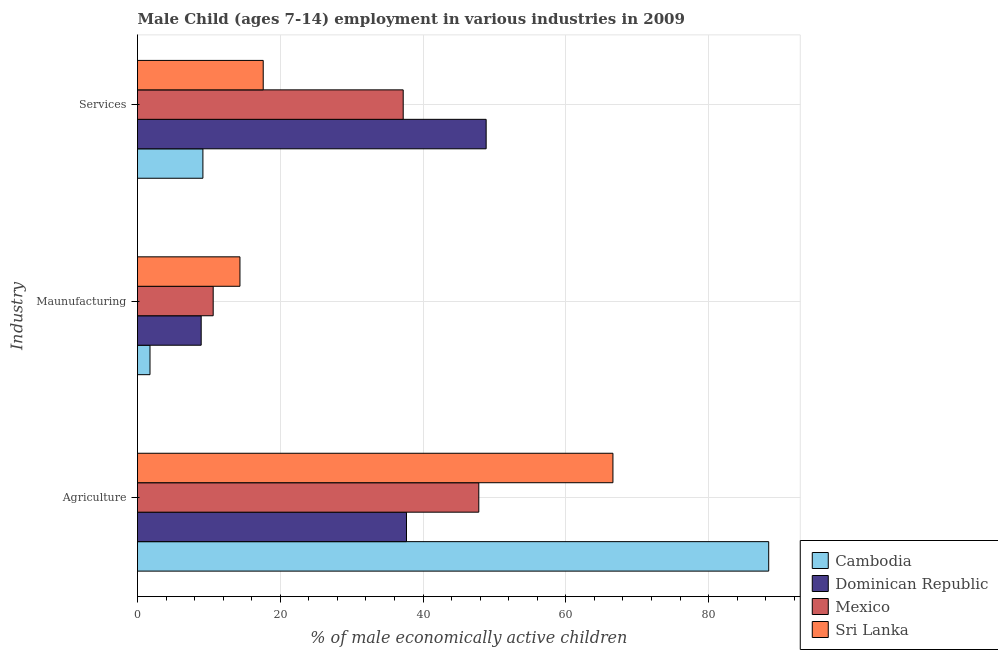Are the number of bars per tick equal to the number of legend labels?
Your answer should be very brief. Yes. Are the number of bars on each tick of the Y-axis equal?
Your answer should be very brief. Yes. How many bars are there on the 3rd tick from the top?
Keep it short and to the point. 4. What is the label of the 1st group of bars from the top?
Offer a terse response. Services. What is the percentage of economically active children in services in Mexico?
Provide a short and direct response. 37.22. Across all countries, what is the maximum percentage of economically active children in manufacturing?
Provide a short and direct response. 14.35. Across all countries, what is the minimum percentage of economically active children in agriculture?
Offer a terse response. 37.68. In which country was the percentage of economically active children in services maximum?
Offer a terse response. Dominican Republic. In which country was the percentage of economically active children in services minimum?
Keep it short and to the point. Cambodia. What is the total percentage of economically active children in agriculture in the graph?
Provide a short and direct response. 240.51. What is the difference between the percentage of economically active children in services in Dominican Republic and that in Cambodia?
Offer a terse response. 39.68. What is the difference between the percentage of economically active children in services in Mexico and the percentage of economically active children in agriculture in Dominican Republic?
Ensure brevity in your answer.  -0.46. What is the average percentage of economically active children in services per country?
Offer a terse response. 28.21. What is the difference between the percentage of economically active children in agriculture and percentage of economically active children in manufacturing in Sri Lanka?
Provide a short and direct response. 52.25. In how many countries, is the percentage of economically active children in services greater than 20 %?
Your answer should be compact. 2. What is the ratio of the percentage of economically active children in agriculture in Sri Lanka to that in Dominican Republic?
Provide a short and direct response. 1.77. Is the difference between the percentage of economically active children in services in Mexico and Dominican Republic greater than the difference between the percentage of economically active children in agriculture in Mexico and Dominican Republic?
Make the answer very short. No. What is the difference between the highest and the second highest percentage of economically active children in agriculture?
Your answer should be compact. 21.82. What is the difference between the highest and the lowest percentage of economically active children in services?
Your response must be concise. 39.68. In how many countries, is the percentage of economically active children in manufacturing greater than the average percentage of economically active children in manufacturing taken over all countries?
Offer a very short reply. 3. What does the 3rd bar from the top in Maunufacturing represents?
Offer a terse response. Dominican Republic. What does the 3rd bar from the bottom in Services represents?
Provide a short and direct response. Mexico. Is it the case that in every country, the sum of the percentage of economically active children in agriculture and percentage of economically active children in manufacturing is greater than the percentage of economically active children in services?
Your response must be concise. No. How many bars are there?
Provide a succinct answer. 12. Are all the bars in the graph horizontal?
Offer a terse response. Yes. What is the difference between two consecutive major ticks on the X-axis?
Provide a succinct answer. 20. Where does the legend appear in the graph?
Your answer should be compact. Bottom right. How many legend labels are there?
Your response must be concise. 4. How are the legend labels stacked?
Provide a succinct answer. Vertical. What is the title of the graph?
Ensure brevity in your answer.  Male Child (ages 7-14) employment in various industries in 2009. What is the label or title of the X-axis?
Make the answer very short. % of male economically active children. What is the label or title of the Y-axis?
Keep it short and to the point. Industry. What is the % of male economically active children in Cambodia in Agriculture?
Make the answer very short. 88.42. What is the % of male economically active children of Dominican Republic in Agriculture?
Your answer should be very brief. 37.68. What is the % of male economically active children in Mexico in Agriculture?
Give a very brief answer. 47.81. What is the % of male economically active children in Sri Lanka in Agriculture?
Give a very brief answer. 66.6. What is the % of male economically active children in Dominican Republic in Maunufacturing?
Offer a very short reply. 8.92. What is the % of male economically active children in Sri Lanka in Maunufacturing?
Offer a terse response. 14.35. What is the % of male economically active children of Cambodia in Services?
Keep it short and to the point. 9.16. What is the % of male economically active children of Dominican Republic in Services?
Your response must be concise. 48.84. What is the % of male economically active children of Mexico in Services?
Provide a succinct answer. 37.22. What is the % of male economically active children in Sri Lanka in Services?
Ensure brevity in your answer.  17.61. Across all Industry, what is the maximum % of male economically active children of Cambodia?
Offer a very short reply. 88.42. Across all Industry, what is the maximum % of male economically active children in Dominican Republic?
Offer a very short reply. 48.84. Across all Industry, what is the maximum % of male economically active children in Mexico?
Provide a succinct answer. 47.81. Across all Industry, what is the maximum % of male economically active children of Sri Lanka?
Make the answer very short. 66.6. Across all Industry, what is the minimum % of male economically active children of Dominican Republic?
Your answer should be compact. 8.92. Across all Industry, what is the minimum % of male economically active children of Sri Lanka?
Provide a succinct answer. 14.35. What is the total % of male economically active children of Cambodia in the graph?
Ensure brevity in your answer.  99.33. What is the total % of male economically active children of Dominican Republic in the graph?
Give a very brief answer. 95.44. What is the total % of male economically active children in Mexico in the graph?
Give a very brief answer. 95.63. What is the total % of male economically active children in Sri Lanka in the graph?
Make the answer very short. 98.56. What is the difference between the % of male economically active children in Cambodia in Agriculture and that in Maunufacturing?
Your answer should be very brief. 86.67. What is the difference between the % of male economically active children of Dominican Republic in Agriculture and that in Maunufacturing?
Offer a terse response. 28.76. What is the difference between the % of male economically active children of Mexico in Agriculture and that in Maunufacturing?
Your answer should be compact. 37.21. What is the difference between the % of male economically active children in Sri Lanka in Agriculture and that in Maunufacturing?
Provide a short and direct response. 52.25. What is the difference between the % of male economically active children of Cambodia in Agriculture and that in Services?
Offer a terse response. 79.26. What is the difference between the % of male economically active children of Dominican Republic in Agriculture and that in Services?
Your answer should be compact. -11.16. What is the difference between the % of male economically active children of Mexico in Agriculture and that in Services?
Ensure brevity in your answer.  10.59. What is the difference between the % of male economically active children of Sri Lanka in Agriculture and that in Services?
Offer a very short reply. 48.99. What is the difference between the % of male economically active children in Cambodia in Maunufacturing and that in Services?
Give a very brief answer. -7.41. What is the difference between the % of male economically active children in Dominican Republic in Maunufacturing and that in Services?
Make the answer very short. -39.92. What is the difference between the % of male economically active children in Mexico in Maunufacturing and that in Services?
Provide a short and direct response. -26.62. What is the difference between the % of male economically active children in Sri Lanka in Maunufacturing and that in Services?
Your response must be concise. -3.26. What is the difference between the % of male economically active children in Cambodia in Agriculture and the % of male economically active children in Dominican Republic in Maunufacturing?
Offer a terse response. 79.5. What is the difference between the % of male economically active children of Cambodia in Agriculture and the % of male economically active children of Mexico in Maunufacturing?
Your response must be concise. 77.82. What is the difference between the % of male economically active children in Cambodia in Agriculture and the % of male economically active children in Sri Lanka in Maunufacturing?
Offer a very short reply. 74.07. What is the difference between the % of male economically active children of Dominican Republic in Agriculture and the % of male economically active children of Mexico in Maunufacturing?
Keep it short and to the point. 27.08. What is the difference between the % of male economically active children in Dominican Republic in Agriculture and the % of male economically active children in Sri Lanka in Maunufacturing?
Offer a very short reply. 23.33. What is the difference between the % of male economically active children in Mexico in Agriculture and the % of male economically active children in Sri Lanka in Maunufacturing?
Give a very brief answer. 33.46. What is the difference between the % of male economically active children of Cambodia in Agriculture and the % of male economically active children of Dominican Republic in Services?
Ensure brevity in your answer.  39.58. What is the difference between the % of male economically active children of Cambodia in Agriculture and the % of male economically active children of Mexico in Services?
Your answer should be very brief. 51.2. What is the difference between the % of male economically active children of Cambodia in Agriculture and the % of male economically active children of Sri Lanka in Services?
Offer a terse response. 70.81. What is the difference between the % of male economically active children of Dominican Republic in Agriculture and the % of male economically active children of Mexico in Services?
Make the answer very short. 0.46. What is the difference between the % of male economically active children in Dominican Republic in Agriculture and the % of male economically active children in Sri Lanka in Services?
Your answer should be very brief. 20.07. What is the difference between the % of male economically active children in Mexico in Agriculture and the % of male economically active children in Sri Lanka in Services?
Provide a short and direct response. 30.2. What is the difference between the % of male economically active children in Cambodia in Maunufacturing and the % of male economically active children in Dominican Republic in Services?
Provide a short and direct response. -47.09. What is the difference between the % of male economically active children of Cambodia in Maunufacturing and the % of male economically active children of Mexico in Services?
Give a very brief answer. -35.47. What is the difference between the % of male economically active children of Cambodia in Maunufacturing and the % of male economically active children of Sri Lanka in Services?
Provide a succinct answer. -15.86. What is the difference between the % of male economically active children of Dominican Republic in Maunufacturing and the % of male economically active children of Mexico in Services?
Offer a terse response. -28.3. What is the difference between the % of male economically active children in Dominican Republic in Maunufacturing and the % of male economically active children in Sri Lanka in Services?
Offer a very short reply. -8.69. What is the difference between the % of male economically active children of Mexico in Maunufacturing and the % of male economically active children of Sri Lanka in Services?
Provide a short and direct response. -7.01. What is the average % of male economically active children of Cambodia per Industry?
Ensure brevity in your answer.  33.11. What is the average % of male economically active children of Dominican Republic per Industry?
Provide a short and direct response. 31.81. What is the average % of male economically active children in Mexico per Industry?
Give a very brief answer. 31.88. What is the average % of male economically active children of Sri Lanka per Industry?
Provide a succinct answer. 32.85. What is the difference between the % of male economically active children in Cambodia and % of male economically active children in Dominican Republic in Agriculture?
Your answer should be compact. 50.74. What is the difference between the % of male economically active children in Cambodia and % of male economically active children in Mexico in Agriculture?
Ensure brevity in your answer.  40.61. What is the difference between the % of male economically active children in Cambodia and % of male economically active children in Sri Lanka in Agriculture?
Your answer should be compact. 21.82. What is the difference between the % of male economically active children of Dominican Republic and % of male economically active children of Mexico in Agriculture?
Provide a succinct answer. -10.13. What is the difference between the % of male economically active children of Dominican Republic and % of male economically active children of Sri Lanka in Agriculture?
Offer a terse response. -28.92. What is the difference between the % of male economically active children in Mexico and % of male economically active children in Sri Lanka in Agriculture?
Your answer should be very brief. -18.79. What is the difference between the % of male economically active children of Cambodia and % of male economically active children of Dominican Republic in Maunufacturing?
Your response must be concise. -7.17. What is the difference between the % of male economically active children of Cambodia and % of male economically active children of Mexico in Maunufacturing?
Your response must be concise. -8.85. What is the difference between the % of male economically active children in Cambodia and % of male economically active children in Sri Lanka in Maunufacturing?
Your response must be concise. -12.6. What is the difference between the % of male economically active children in Dominican Republic and % of male economically active children in Mexico in Maunufacturing?
Give a very brief answer. -1.68. What is the difference between the % of male economically active children in Dominican Republic and % of male economically active children in Sri Lanka in Maunufacturing?
Offer a very short reply. -5.43. What is the difference between the % of male economically active children in Mexico and % of male economically active children in Sri Lanka in Maunufacturing?
Offer a terse response. -3.75. What is the difference between the % of male economically active children of Cambodia and % of male economically active children of Dominican Republic in Services?
Keep it short and to the point. -39.68. What is the difference between the % of male economically active children of Cambodia and % of male economically active children of Mexico in Services?
Provide a short and direct response. -28.06. What is the difference between the % of male economically active children of Cambodia and % of male economically active children of Sri Lanka in Services?
Offer a very short reply. -8.45. What is the difference between the % of male economically active children of Dominican Republic and % of male economically active children of Mexico in Services?
Ensure brevity in your answer.  11.62. What is the difference between the % of male economically active children in Dominican Republic and % of male economically active children in Sri Lanka in Services?
Make the answer very short. 31.23. What is the difference between the % of male economically active children in Mexico and % of male economically active children in Sri Lanka in Services?
Your response must be concise. 19.61. What is the ratio of the % of male economically active children of Cambodia in Agriculture to that in Maunufacturing?
Keep it short and to the point. 50.53. What is the ratio of the % of male economically active children of Dominican Republic in Agriculture to that in Maunufacturing?
Give a very brief answer. 4.22. What is the ratio of the % of male economically active children in Mexico in Agriculture to that in Maunufacturing?
Provide a short and direct response. 4.51. What is the ratio of the % of male economically active children of Sri Lanka in Agriculture to that in Maunufacturing?
Offer a terse response. 4.64. What is the ratio of the % of male economically active children in Cambodia in Agriculture to that in Services?
Make the answer very short. 9.65. What is the ratio of the % of male economically active children in Dominican Republic in Agriculture to that in Services?
Make the answer very short. 0.77. What is the ratio of the % of male economically active children in Mexico in Agriculture to that in Services?
Your response must be concise. 1.28. What is the ratio of the % of male economically active children of Sri Lanka in Agriculture to that in Services?
Keep it short and to the point. 3.78. What is the ratio of the % of male economically active children of Cambodia in Maunufacturing to that in Services?
Keep it short and to the point. 0.19. What is the ratio of the % of male economically active children in Dominican Republic in Maunufacturing to that in Services?
Provide a succinct answer. 0.18. What is the ratio of the % of male economically active children of Mexico in Maunufacturing to that in Services?
Your answer should be very brief. 0.28. What is the ratio of the % of male economically active children in Sri Lanka in Maunufacturing to that in Services?
Offer a very short reply. 0.81. What is the difference between the highest and the second highest % of male economically active children in Cambodia?
Offer a terse response. 79.26. What is the difference between the highest and the second highest % of male economically active children in Dominican Republic?
Keep it short and to the point. 11.16. What is the difference between the highest and the second highest % of male economically active children of Mexico?
Your answer should be very brief. 10.59. What is the difference between the highest and the second highest % of male economically active children of Sri Lanka?
Keep it short and to the point. 48.99. What is the difference between the highest and the lowest % of male economically active children of Cambodia?
Your response must be concise. 86.67. What is the difference between the highest and the lowest % of male economically active children of Dominican Republic?
Provide a succinct answer. 39.92. What is the difference between the highest and the lowest % of male economically active children of Mexico?
Provide a short and direct response. 37.21. What is the difference between the highest and the lowest % of male economically active children of Sri Lanka?
Offer a very short reply. 52.25. 